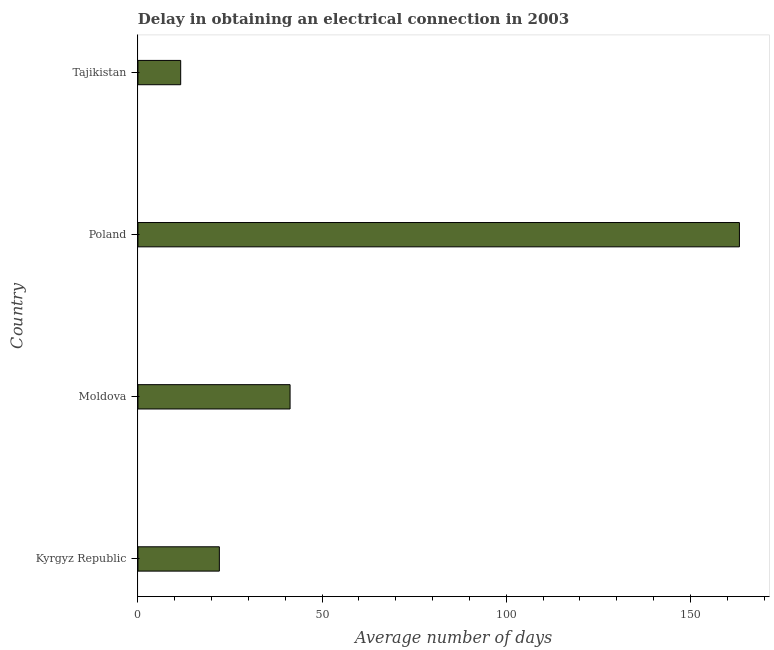Does the graph contain any zero values?
Ensure brevity in your answer.  No. What is the title of the graph?
Make the answer very short. Delay in obtaining an electrical connection in 2003. What is the label or title of the X-axis?
Your answer should be very brief. Average number of days. What is the label or title of the Y-axis?
Your answer should be compact. Country. What is the dalay in electrical connection in Moldova?
Provide a succinct answer. 41.3. Across all countries, what is the maximum dalay in electrical connection?
Your answer should be very brief. 163.3. Across all countries, what is the minimum dalay in electrical connection?
Your answer should be compact. 11.6. In which country was the dalay in electrical connection minimum?
Your response must be concise. Tajikistan. What is the sum of the dalay in electrical connection?
Your answer should be compact. 238.3. What is the difference between the dalay in electrical connection in Kyrgyz Republic and Poland?
Your answer should be very brief. -141.2. What is the average dalay in electrical connection per country?
Your response must be concise. 59.58. What is the median dalay in electrical connection?
Give a very brief answer. 31.7. What is the ratio of the dalay in electrical connection in Moldova to that in Tajikistan?
Provide a succinct answer. 3.56. What is the difference between the highest and the second highest dalay in electrical connection?
Provide a succinct answer. 122. What is the difference between the highest and the lowest dalay in electrical connection?
Offer a very short reply. 151.7. In how many countries, is the dalay in electrical connection greater than the average dalay in electrical connection taken over all countries?
Your response must be concise. 1. Are all the bars in the graph horizontal?
Your response must be concise. Yes. Are the values on the major ticks of X-axis written in scientific E-notation?
Give a very brief answer. No. What is the Average number of days of Kyrgyz Republic?
Offer a very short reply. 22.1. What is the Average number of days of Moldova?
Make the answer very short. 41.3. What is the Average number of days in Poland?
Your response must be concise. 163.3. What is the Average number of days in Tajikistan?
Your response must be concise. 11.6. What is the difference between the Average number of days in Kyrgyz Republic and Moldova?
Make the answer very short. -19.2. What is the difference between the Average number of days in Kyrgyz Republic and Poland?
Your answer should be compact. -141.2. What is the difference between the Average number of days in Kyrgyz Republic and Tajikistan?
Provide a short and direct response. 10.5. What is the difference between the Average number of days in Moldova and Poland?
Provide a short and direct response. -122. What is the difference between the Average number of days in Moldova and Tajikistan?
Provide a succinct answer. 29.7. What is the difference between the Average number of days in Poland and Tajikistan?
Offer a terse response. 151.7. What is the ratio of the Average number of days in Kyrgyz Republic to that in Moldova?
Your response must be concise. 0.54. What is the ratio of the Average number of days in Kyrgyz Republic to that in Poland?
Ensure brevity in your answer.  0.14. What is the ratio of the Average number of days in Kyrgyz Republic to that in Tajikistan?
Your answer should be very brief. 1.91. What is the ratio of the Average number of days in Moldova to that in Poland?
Your answer should be very brief. 0.25. What is the ratio of the Average number of days in Moldova to that in Tajikistan?
Provide a short and direct response. 3.56. What is the ratio of the Average number of days in Poland to that in Tajikistan?
Give a very brief answer. 14.08. 